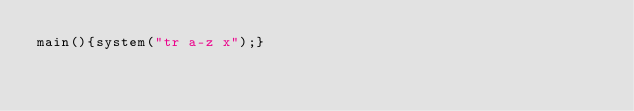Convert code to text. <code><loc_0><loc_0><loc_500><loc_500><_C_>main(){system("tr a-z x");}</code> 